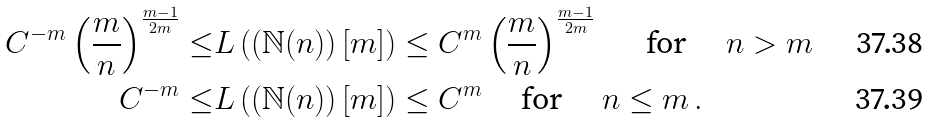<formula> <loc_0><loc_0><loc_500><loc_500>C ^ { - m } \left ( \frac { m } { n } \right ) ^ { \frac { m - 1 } { 2 m } } \leq & L \left ( \left ( \mathbb { N } ( n ) \right ) [ m ] \right ) \leq C ^ { m } \left ( \frac { m } { n } \right ) ^ { \frac { m - 1 } { 2 m } } \quad \, \text { for } \quad n > m \\ C ^ { - m } \leq & L \left ( \left ( \mathbb { N } ( n ) \right ) [ m ] \right ) \leq C ^ { m } \quad \text { for } \quad n \leq m \, .</formula> 